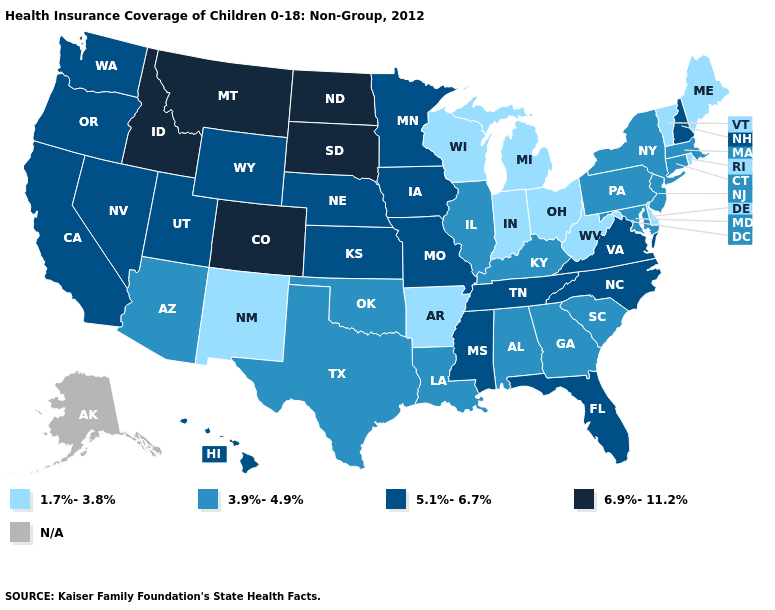Does Delaware have the lowest value in the USA?
Short answer required. Yes. Name the states that have a value in the range 6.9%-11.2%?
Be succinct. Colorado, Idaho, Montana, North Dakota, South Dakota. Which states have the lowest value in the South?
Answer briefly. Arkansas, Delaware, West Virginia. Among the states that border Illinois , which have the lowest value?
Keep it brief. Indiana, Wisconsin. Among the states that border Washington , does Idaho have the lowest value?
Give a very brief answer. No. What is the value of Connecticut?
Write a very short answer. 3.9%-4.9%. Does the first symbol in the legend represent the smallest category?
Quick response, please. Yes. Name the states that have a value in the range 6.9%-11.2%?
Give a very brief answer. Colorado, Idaho, Montana, North Dakota, South Dakota. Name the states that have a value in the range 3.9%-4.9%?
Short answer required. Alabama, Arizona, Connecticut, Georgia, Illinois, Kentucky, Louisiana, Maryland, Massachusetts, New Jersey, New York, Oklahoma, Pennsylvania, South Carolina, Texas. What is the highest value in states that border Maryland?
Concise answer only. 5.1%-6.7%. What is the value of Maine?
Be succinct. 1.7%-3.8%. 